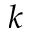<formula> <loc_0><loc_0><loc_500><loc_500>k</formula> 